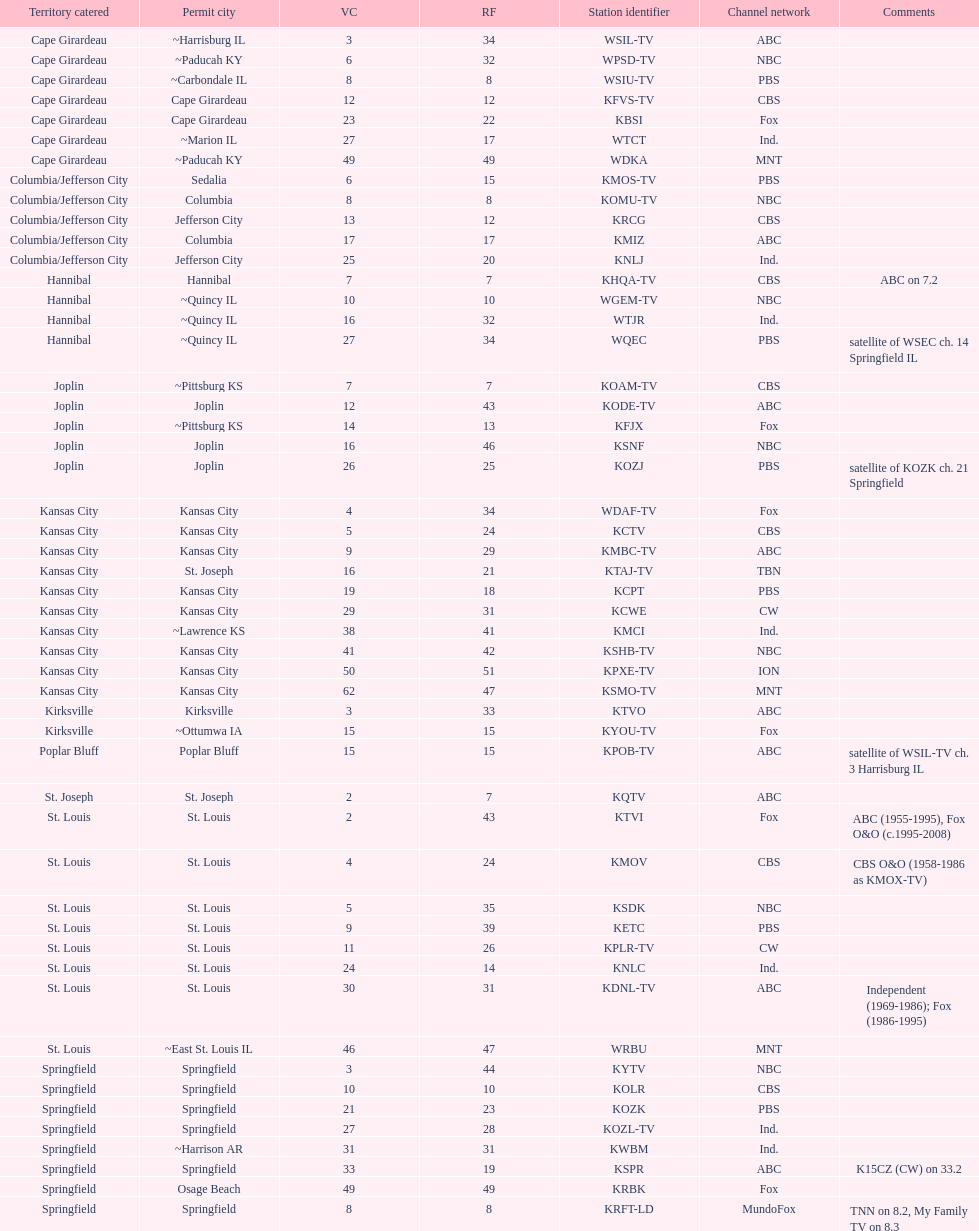How many areas have at least 5 stations? 6. Would you be able to parse every entry in this table? {'header': ['Territory catered', 'Permit city', 'VC', 'RF', 'Station identifier', 'Channel network', 'Comments'], 'rows': [['Cape Girardeau', '~Harrisburg IL', '3', '34', 'WSIL-TV', 'ABC', ''], ['Cape Girardeau', '~Paducah KY', '6', '32', 'WPSD-TV', 'NBC', ''], ['Cape Girardeau', '~Carbondale IL', '8', '8', 'WSIU-TV', 'PBS', ''], ['Cape Girardeau', 'Cape Girardeau', '12', '12', 'KFVS-TV', 'CBS', ''], ['Cape Girardeau', 'Cape Girardeau', '23', '22', 'KBSI', 'Fox', ''], ['Cape Girardeau', '~Marion IL', '27', '17', 'WTCT', 'Ind.', ''], ['Cape Girardeau', '~Paducah KY', '49', '49', 'WDKA', 'MNT', ''], ['Columbia/Jefferson City', 'Sedalia', '6', '15', 'KMOS-TV', 'PBS', ''], ['Columbia/Jefferson City', 'Columbia', '8', '8', 'KOMU-TV', 'NBC', ''], ['Columbia/Jefferson City', 'Jefferson City', '13', '12', 'KRCG', 'CBS', ''], ['Columbia/Jefferson City', 'Columbia', '17', '17', 'KMIZ', 'ABC', ''], ['Columbia/Jefferson City', 'Jefferson City', '25', '20', 'KNLJ', 'Ind.', ''], ['Hannibal', 'Hannibal', '7', '7', 'KHQA-TV', 'CBS', 'ABC on 7.2'], ['Hannibal', '~Quincy IL', '10', '10', 'WGEM-TV', 'NBC', ''], ['Hannibal', '~Quincy IL', '16', '32', 'WTJR', 'Ind.', ''], ['Hannibal', '~Quincy IL', '27', '34', 'WQEC', 'PBS', 'satellite of WSEC ch. 14 Springfield IL'], ['Joplin', '~Pittsburg KS', '7', '7', 'KOAM-TV', 'CBS', ''], ['Joplin', 'Joplin', '12', '43', 'KODE-TV', 'ABC', ''], ['Joplin', '~Pittsburg KS', '14', '13', 'KFJX', 'Fox', ''], ['Joplin', 'Joplin', '16', '46', 'KSNF', 'NBC', ''], ['Joplin', 'Joplin', '26', '25', 'KOZJ', 'PBS', 'satellite of KOZK ch. 21 Springfield'], ['Kansas City', 'Kansas City', '4', '34', 'WDAF-TV', 'Fox', ''], ['Kansas City', 'Kansas City', '5', '24', 'KCTV', 'CBS', ''], ['Kansas City', 'Kansas City', '9', '29', 'KMBC-TV', 'ABC', ''], ['Kansas City', 'St. Joseph', '16', '21', 'KTAJ-TV', 'TBN', ''], ['Kansas City', 'Kansas City', '19', '18', 'KCPT', 'PBS', ''], ['Kansas City', 'Kansas City', '29', '31', 'KCWE', 'CW', ''], ['Kansas City', '~Lawrence KS', '38', '41', 'KMCI', 'Ind.', ''], ['Kansas City', 'Kansas City', '41', '42', 'KSHB-TV', 'NBC', ''], ['Kansas City', 'Kansas City', '50', '51', 'KPXE-TV', 'ION', ''], ['Kansas City', 'Kansas City', '62', '47', 'KSMO-TV', 'MNT', ''], ['Kirksville', 'Kirksville', '3', '33', 'KTVO', 'ABC', ''], ['Kirksville', '~Ottumwa IA', '15', '15', 'KYOU-TV', 'Fox', ''], ['Poplar Bluff', 'Poplar Bluff', '15', '15', 'KPOB-TV', 'ABC', 'satellite of WSIL-TV ch. 3 Harrisburg IL'], ['St. Joseph', 'St. Joseph', '2', '7', 'KQTV', 'ABC', ''], ['St. Louis', 'St. Louis', '2', '43', 'KTVI', 'Fox', 'ABC (1955-1995), Fox O&O (c.1995-2008)'], ['St. Louis', 'St. Louis', '4', '24', 'KMOV', 'CBS', 'CBS O&O (1958-1986 as KMOX-TV)'], ['St. Louis', 'St. Louis', '5', '35', 'KSDK', 'NBC', ''], ['St. Louis', 'St. Louis', '9', '39', 'KETC', 'PBS', ''], ['St. Louis', 'St. Louis', '11', '26', 'KPLR-TV', 'CW', ''], ['St. Louis', 'St. Louis', '24', '14', 'KNLC', 'Ind.', ''], ['St. Louis', 'St. Louis', '30', '31', 'KDNL-TV', 'ABC', 'Independent (1969-1986); Fox (1986-1995)'], ['St. Louis', '~East St. Louis IL', '46', '47', 'WRBU', 'MNT', ''], ['Springfield', 'Springfield', '3', '44', 'KYTV', 'NBC', ''], ['Springfield', 'Springfield', '10', '10', 'KOLR', 'CBS', ''], ['Springfield', 'Springfield', '21', '23', 'KOZK', 'PBS', ''], ['Springfield', 'Springfield', '27', '28', 'KOZL-TV', 'Ind.', ''], ['Springfield', '~Harrison AR', '31', '31', 'KWBM', 'Ind.', ''], ['Springfield', 'Springfield', '33', '19', 'KSPR', 'ABC', 'K15CZ (CW) on 33.2'], ['Springfield', 'Osage Beach', '49', '49', 'KRBK', 'Fox', ''], ['Springfield', 'Springfield', '8', '8', 'KRFT-LD', 'MundoFox', 'TNN on 8.2, My Family TV on 8.3']]} 